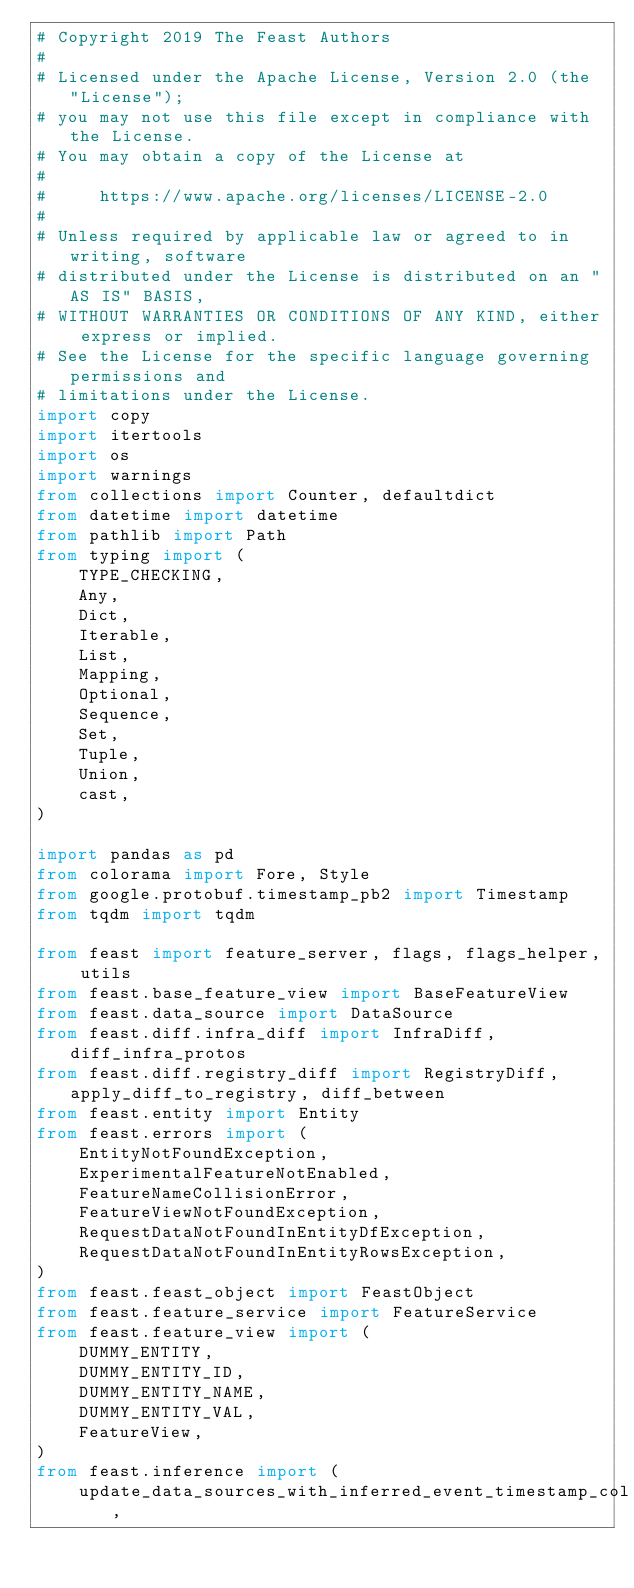<code> <loc_0><loc_0><loc_500><loc_500><_Python_># Copyright 2019 The Feast Authors
#
# Licensed under the Apache License, Version 2.0 (the "License");
# you may not use this file except in compliance with the License.
# You may obtain a copy of the License at
#
#     https://www.apache.org/licenses/LICENSE-2.0
#
# Unless required by applicable law or agreed to in writing, software
# distributed under the License is distributed on an "AS IS" BASIS,
# WITHOUT WARRANTIES OR CONDITIONS OF ANY KIND, either express or implied.
# See the License for the specific language governing permissions and
# limitations under the License.
import copy
import itertools
import os
import warnings
from collections import Counter, defaultdict
from datetime import datetime
from pathlib import Path
from typing import (
    TYPE_CHECKING,
    Any,
    Dict,
    Iterable,
    List,
    Mapping,
    Optional,
    Sequence,
    Set,
    Tuple,
    Union,
    cast,
)

import pandas as pd
from colorama import Fore, Style
from google.protobuf.timestamp_pb2 import Timestamp
from tqdm import tqdm

from feast import feature_server, flags, flags_helper, utils
from feast.base_feature_view import BaseFeatureView
from feast.data_source import DataSource
from feast.diff.infra_diff import InfraDiff, diff_infra_protos
from feast.diff.registry_diff import RegistryDiff, apply_diff_to_registry, diff_between
from feast.entity import Entity
from feast.errors import (
    EntityNotFoundException,
    ExperimentalFeatureNotEnabled,
    FeatureNameCollisionError,
    FeatureViewNotFoundException,
    RequestDataNotFoundInEntityDfException,
    RequestDataNotFoundInEntityRowsException,
)
from feast.feast_object import FeastObject
from feast.feature_service import FeatureService
from feast.feature_view import (
    DUMMY_ENTITY,
    DUMMY_ENTITY_ID,
    DUMMY_ENTITY_NAME,
    DUMMY_ENTITY_VAL,
    FeatureView,
)
from feast.inference import (
    update_data_sources_with_inferred_event_timestamp_col,</code> 